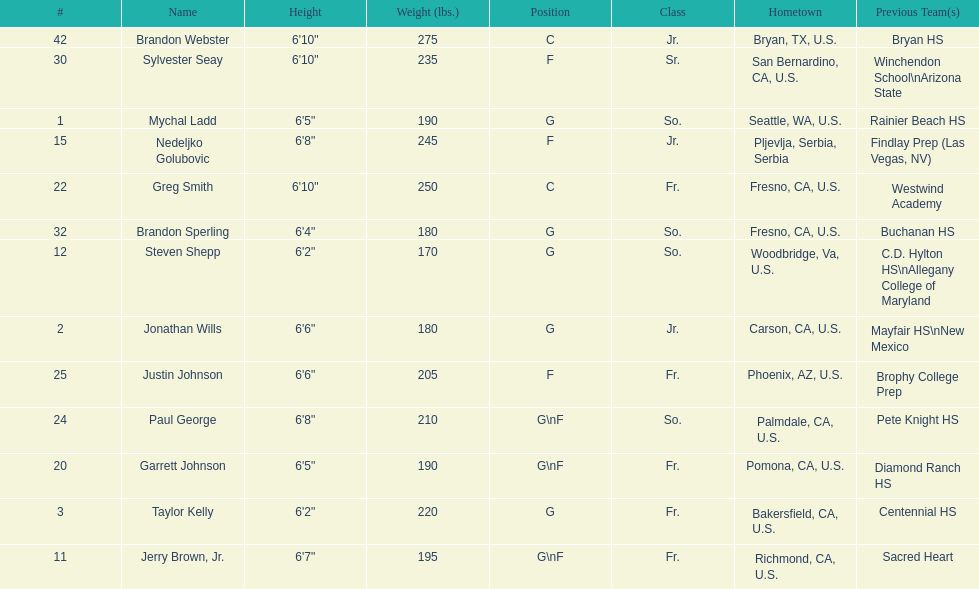How many players hometowns are outside of california? 5. 